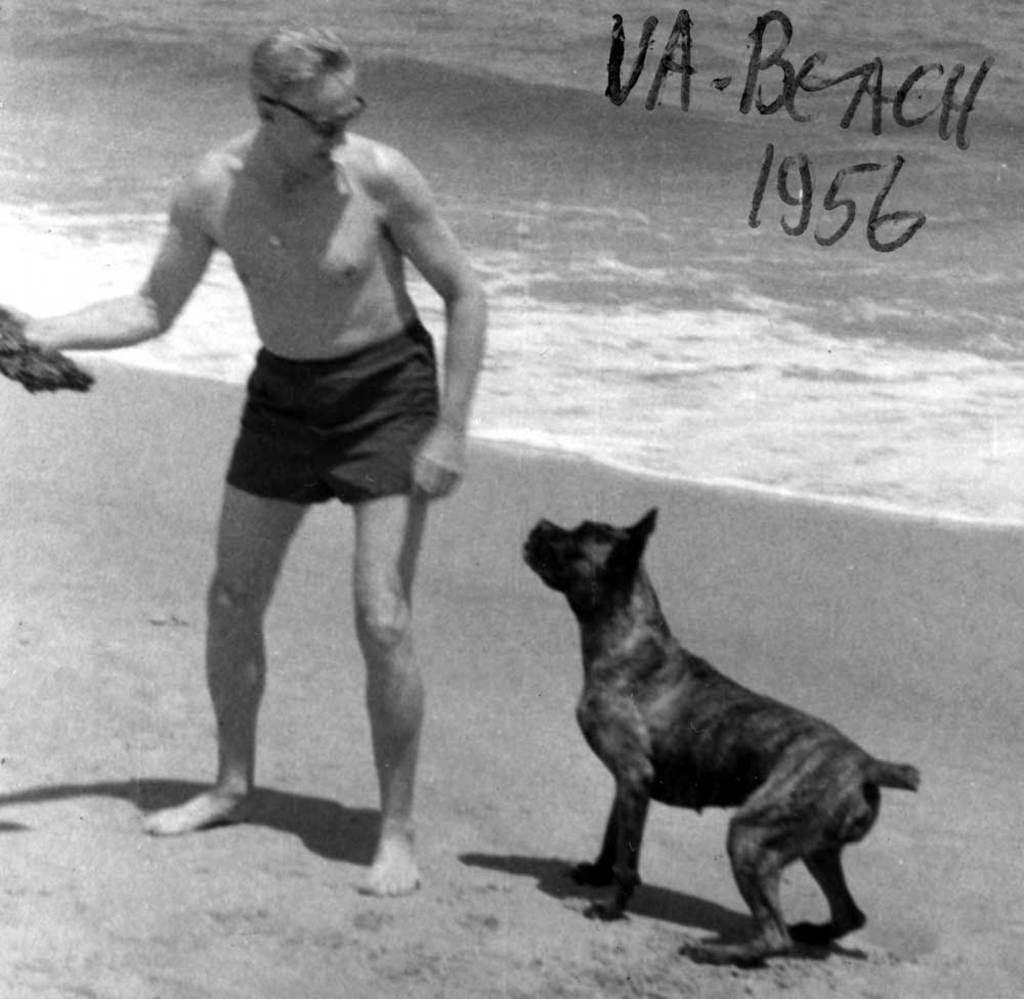Describe this image in one or two sentences. This is a black and white picture. In this a person is holding something and wearing a goggles. Near to him there is a dog. In the back there is water. On the image something is written. 